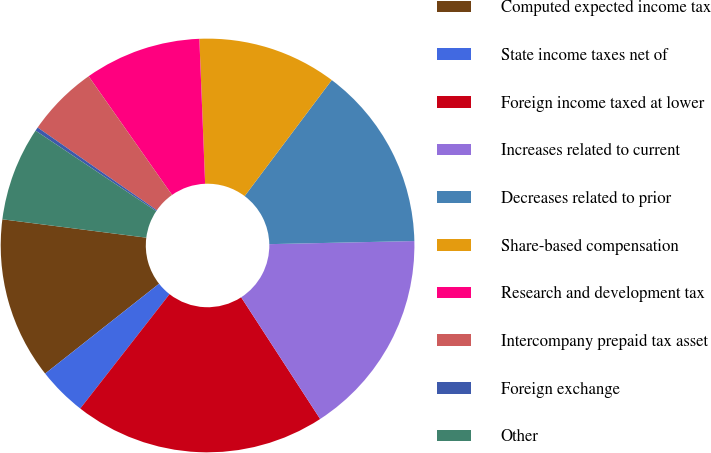Convert chart. <chart><loc_0><loc_0><loc_500><loc_500><pie_chart><fcel>Computed expected income tax<fcel>State income taxes net of<fcel>Foreign income taxed at lower<fcel>Increases related to current<fcel>Decreases related to prior<fcel>Share-based compensation<fcel>Research and development tax<fcel>Intercompany prepaid tax asset<fcel>Foreign exchange<fcel>Other<nl><fcel>12.65%<fcel>3.82%<fcel>19.71%<fcel>16.18%<fcel>14.41%<fcel>10.88%<fcel>9.12%<fcel>5.59%<fcel>0.29%<fcel>7.35%<nl></chart> 